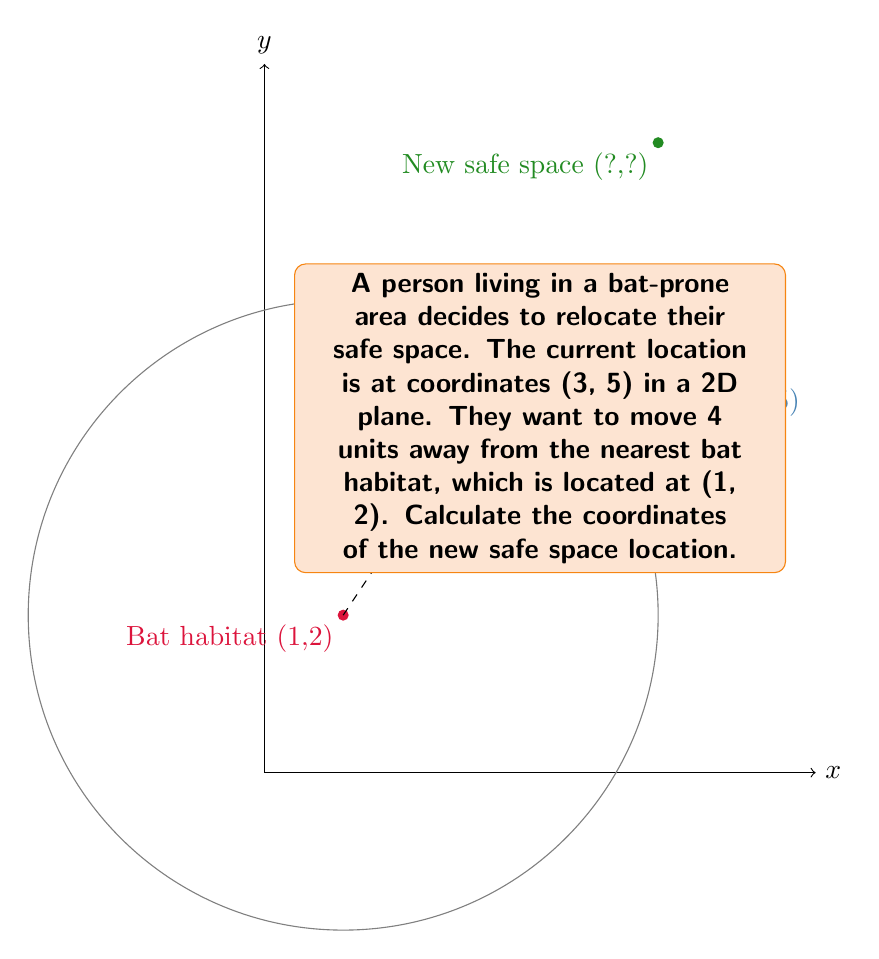Can you solve this math problem? To find the new coordinates, we need to:

1. Calculate the vector from the bat habitat to the current safe space:
   $\vec{v} = (3-1, 5-2) = (2, 3)$

2. Normalize this vector:
   $\|\vec{v}\| = \sqrt{2^2 + 3^2} = \sqrt{13}$
   $\hat{v} = (\frac{2}{\sqrt{13}}, \frac{3}{\sqrt{13}})$

3. Multiply the normalized vector by the desired distance (4 units):
   $4\hat{v} = (4 \cdot \frac{2}{\sqrt{13}}, 4 \cdot \frac{3}{\sqrt{13}}) = (\frac{8}{\sqrt{13}}, \frac{12}{\sqrt{13}})$

4. Add this vector to the bat habitat coordinates:
   New coordinates = $(1 + \frac{8}{\sqrt{13}}, 2 + \frac{12}{\sqrt{13}})$

5. Simplify:
   $x = 1 + \frac{8}{\sqrt{13}} \approx 3.22$
   $y = 2 + \frac{12}{\sqrt{13}} \approx 5.33$

Therefore, the new safe space coordinates are approximately (3.22, 5.33).
Answer: $(1 + \frac{8}{\sqrt{13}}, 2 + \frac{12}{\sqrt{13}})$ or approximately (3.22, 5.33) 